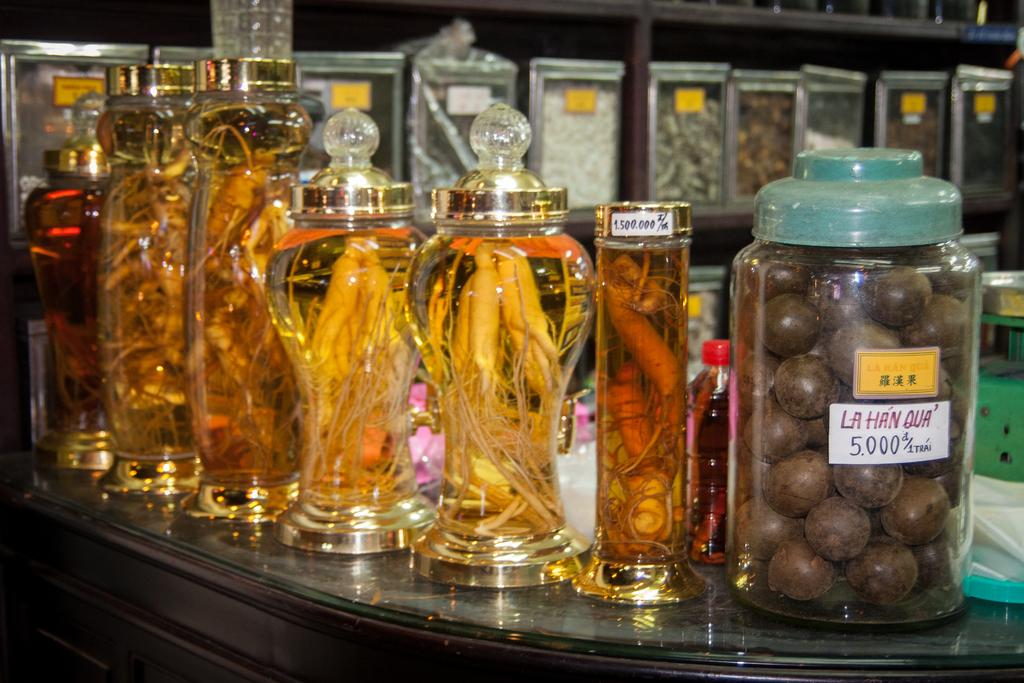Provide a one-sentence caption for the provided image. Glass jars display many different things on a counter, including something that looks like chocolate balls and says La Han Qua. 